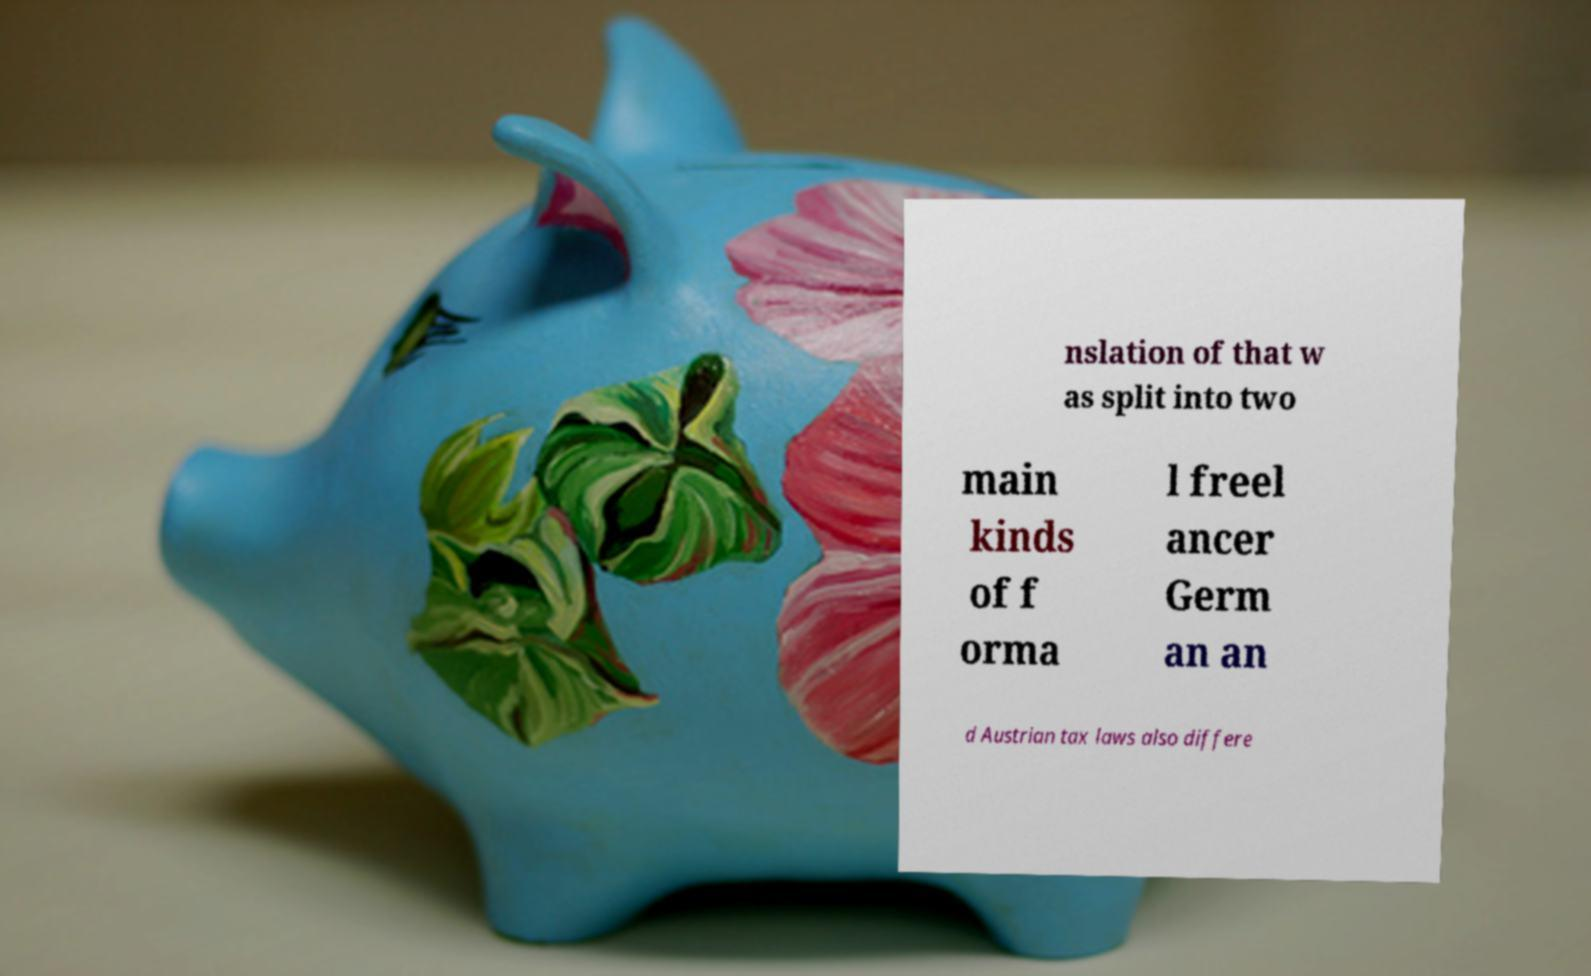For documentation purposes, I need the text within this image transcribed. Could you provide that? nslation of that w as split into two main kinds of f orma l freel ancer Germ an an d Austrian tax laws also differe 